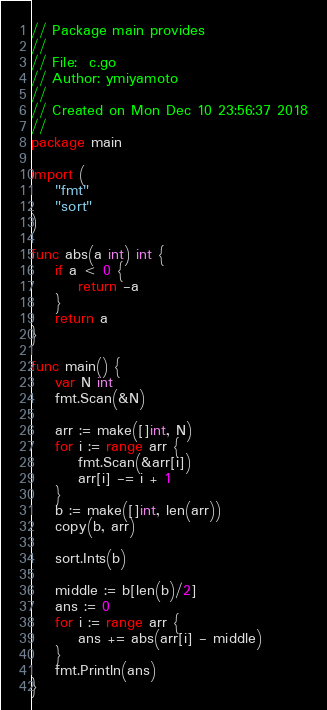Convert code to text. <code><loc_0><loc_0><loc_500><loc_500><_Go_>// Package main provides
//
// File:  c.go
// Author: ymiyamoto
//
// Created on Mon Dec 10 23:56:37 2018
//
package main

import (
	"fmt"
	"sort"
)

func abs(a int) int {
	if a < 0 {
		return -a
	}
	return a
}

func main() {
	var N int
	fmt.Scan(&N)

	arr := make([]int, N)
	for i := range arr {
		fmt.Scan(&arr[i])
		arr[i] -= i + 1
	}
	b := make([]int, len(arr))
	copy(b, arr)

	sort.Ints(b)

	middle := b[len(b)/2]
	ans := 0
	for i := range arr {
		ans += abs(arr[i] - middle)
	}
	fmt.Println(ans)
}
</code> 